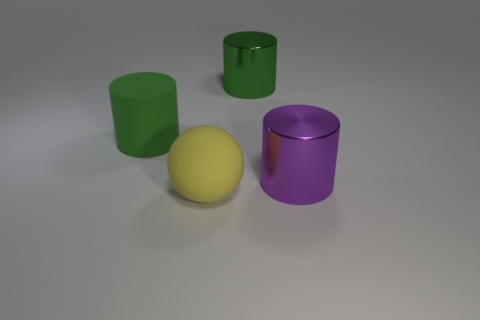Add 2 large green metallic cylinders. How many objects exist? 6 Subtract all large green cylinders. How many cylinders are left? 1 Subtract all spheres. How many objects are left? 3 Subtract 1 cylinders. How many cylinders are left? 2 Add 1 spheres. How many spheres exist? 2 Subtract all purple cylinders. How many cylinders are left? 2 Subtract 2 green cylinders. How many objects are left? 2 Subtract all purple cylinders. Subtract all brown blocks. How many cylinders are left? 2 Subtract all green cubes. How many purple cylinders are left? 1 Subtract all green metallic objects. Subtract all purple cylinders. How many objects are left? 2 